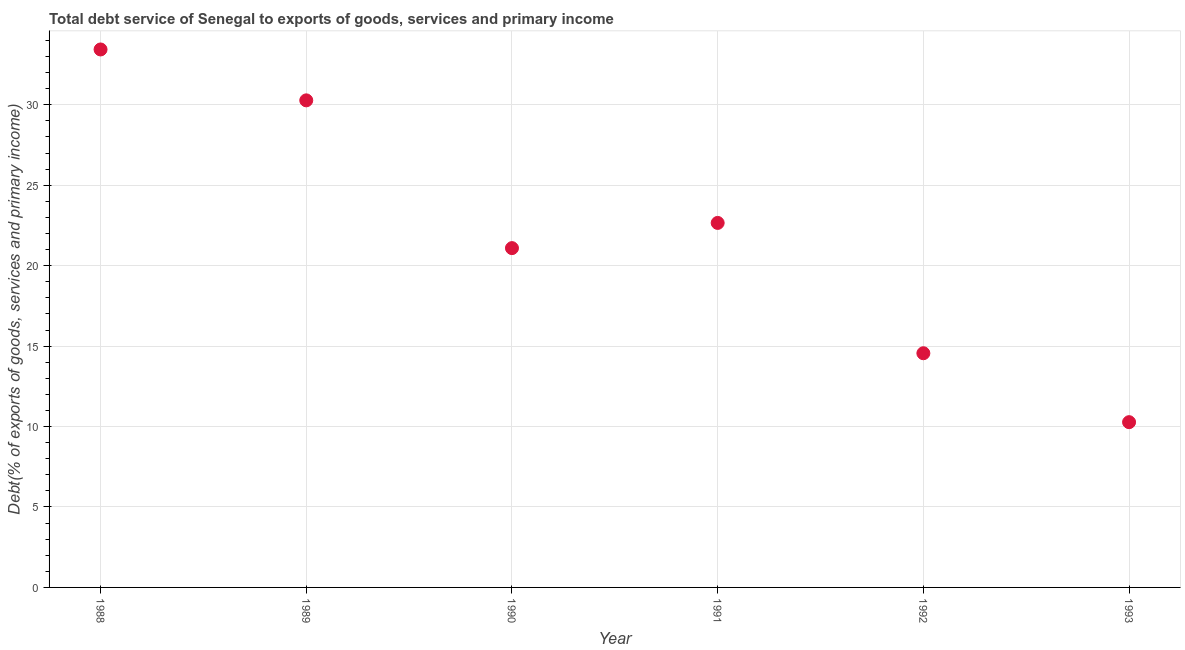What is the total debt service in 1992?
Provide a succinct answer. 14.56. Across all years, what is the maximum total debt service?
Your response must be concise. 33.44. Across all years, what is the minimum total debt service?
Provide a succinct answer. 10.27. What is the sum of the total debt service?
Provide a succinct answer. 132.29. What is the difference between the total debt service in 1988 and 1991?
Offer a very short reply. 10.78. What is the average total debt service per year?
Your answer should be very brief. 22.05. What is the median total debt service?
Keep it short and to the point. 21.87. What is the ratio of the total debt service in 1988 to that in 1991?
Your response must be concise. 1.48. Is the total debt service in 1988 less than that in 1992?
Your answer should be very brief. No. What is the difference between the highest and the second highest total debt service?
Provide a succinct answer. 3.16. What is the difference between the highest and the lowest total debt service?
Ensure brevity in your answer.  23.17. In how many years, is the total debt service greater than the average total debt service taken over all years?
Offer a terse response. 3. Does the total debt service monotonically increase over the years?
Provide a succinct answer. No. Does the graph contain grids?
Provide a short and direct response. Yes. What is the title of the graph?
Make the answer very short. Total debt service of Senegal to exports of goods, services and primary income. What is the label or title of the X-axis?
Offer a terse response. Year. What is the label or title of the Y-axis?
Your answer should be very brief. Debt(% of exports of goods, services and primary income). What is the Debt(% of exports of goods, services and primary income) in 1988?
Offer a terse response. 33.44. What is the Debt(% of exports of goods, services and primary income) in 1989?
Your answer should be very brief. 30.28. What is the Debt(% of exports of goods, services and primary income) in 1990?
Provide a succinct answer. 21.09. What is the Debt(% of exports of goods, services and primary income) in 1991?
Make the answer very short. 22.66. What is the Debt(% of exports of goods, services and primary income) in 1992?
Your answer should be compact. 14.56. What is the Debt(% of exports of goods, services and primary income) in 1993?
Make the answer very short. 10.27. What is the difference between the Debt(% of exports of goods, services and primary income) in 1988 and 1989?
Provide a short and direct response. 3.16. What is the difference between the Debt(% of exports of goods, services and primary income) in 1988 and 1990?
Your response must be concise. 12.35. What is the difference between the Debt(% of exports of goods, services and primary income) in 1988 and 1991?
Your answer should be compact. 10.78. What is the difference between the Debt(% of exports of goods, services and primary income) in 1988 and 1992?
Ensure brevity in your answer.  18.88. What is the difference between the Debt(% of exports of goods, services and primary income) in 1988 and 1993?
Make the answer very short. 23.17. What is the difference between the Debt(% of exports of goods, services and primary income) in 1989 and 1990?
Offer a very short reply. 9.18. What is the difference between the Debt(% of exports of goods, services and primary income) in 1989 and 1991?
Offer a very short reply. 7.62. What is the difference between the Debt(% of exports of goods, services and primary income) in 1989 and 1992?
Your answer should be compact. 15.72. What is the difference between the Debt(% of exports of goods, services and primary income) in 1989 and 1993?
Your answer should be very brief. 20. What is the difference between the Debt(% of exports of goods, services and primary income) in 1990 and 1991?
Keep it short and to the point. -1.57. What is the difference between the Debt(% of exports of goods, services and primary income) in 1990 and 1992?
Make the answer very short. 6.53. What is the difference between the Debt(% of exports of goods, services and primary income) in 1990 and 1993?
Provide a short and direct response. 10.82. What is the difference between the Debt(% of exports of goods, services and primary income) in 1991 and 1992?
Offer a terse response. 8.1. What is the difference between the Debt(% of exports of goods, services and primary income) in 1991 and 1993?
Your answer should be compact. 12.38. What is the difference between the Debt(% of exports of goods, services and primary income) in 1992 and 1993?
Offer a very short reply. 4.28. What is the ratio of the Debt(% of exports of goods, services and primary income) in 1988 to that in 1989?
Offer a very short reply. 1.1. What is the ratio of the Debt(% of exports of goods, services and primary income) in 1988 to that in 1990?
Give a very brief answer. 1.59. What is the ratio of the Debt(% of exports of goods, services and primary income) in 1988 to that in 1991?
Give a very brief answer. 1.48. What is the ratio of the Debt(% of exports of goods, services and primary income) in 1988 to that in 1992?
Give a very brief answer. 2.3. What is the ratio of the Debt(% of exports of goods, services and primary income) in 1988 to that in 1993?
Your response must be concise. 3.25. What is the ratio of the Debt(% of exports of goods, services and primary income) in 1989 to that in 1990?
Offer a terse response. 1.44. What is the ratio of the Debt(% of exports of goods, services and primary income) in 1989 to that in 1991?
Your answer should be very brief. 1.34. What is the ratio of the Debt(% of exports of goods, services and primary income) in 1989 to that in 1992?
Make the answer very short. 2.08. What is the ratio of the Debt(% of exports of goods, services and primary income) in 1989 to that in 1993?
Give a very brief answer. 2.95. What is the ratio of the Debt(% of exports of goods, services and primary income) in 1990 to that in 1992?
Keep it short and to the point. 1.45. What is the ratio of the Debt(% of exports of goods, services and primary income) in 1990 to that in 1993?
Ensure brevity in your answer.  2.05. What is the ratio of the Debt(% of exports of goods, services and primary income) in 1991 to that in 1992?
Give a very brief answer. 1.56. What is the ratio of the Debt(% of exports of goods, services and primary income) in 1991 to that in 1993?
Make the answer very short. 2.21. What is the ratio of the Debt(% of exports of goods, services and primary income) in 1992 to that in 1993?
Offer a very short reply. 1.42. 